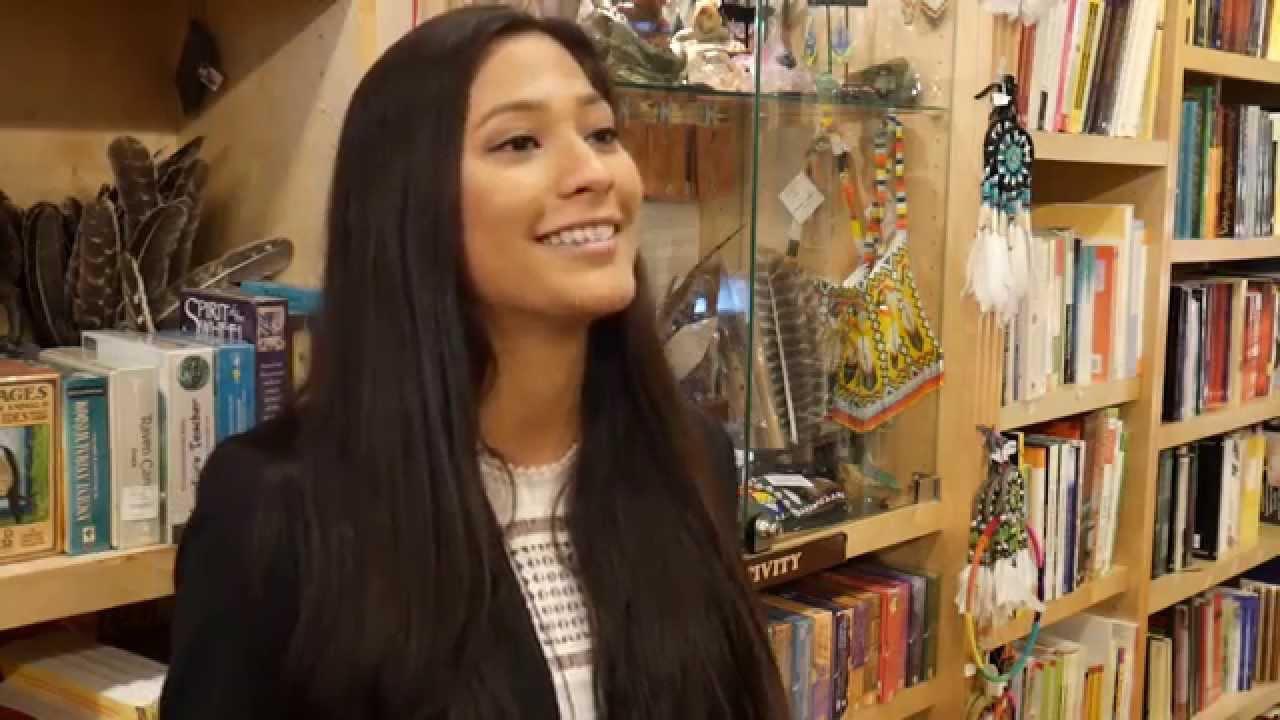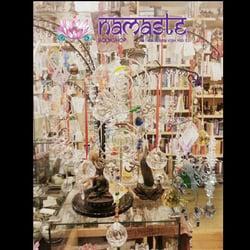The first image is the image on the left, the second image is the image on the right. For the images shown, is this caption "A woman with dark hair and wearing a black jacket is in a bookstore in one image." true? Answer yes or no. Yes. The first image is the image on the left, the second image is the image on the right. Analyze the images presented: Is the assertion "there is exactly one person in the image on the left" valid? Answer yes or no. Yes. The first image is the image on the left, the second image is the image on the right. Considering the images on both sides, is "There is one woman wearing black in the lefthand image." valid? Answer yes or no. Yes. The first image is the image on the left, the second image is the image on the right. Analyze the images presented: Is the assertion "Left image contains a person wearing a black blazer." valid? Answer yes or no. Yes. 